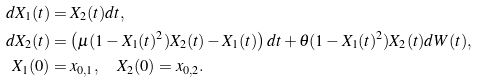Convert formula to latex. <formula><loc_0><loc_0><loc_500><loc_500>d X _ { 1 } ( t ) & = X _ { 2 } ( t ) d t , \\ d X _ { 2 } ( t ) & = \left ( \mu ( 1 - X _ { 1 } ( t ) ^ { 2 } ) X _ { 2 } ( t ) - X _ { 1 } ( t ) \right ) d t + \theta ( 1 - X _ { 1 } ( t ) ^ { 2 } ) X _ { 2 } ( t ) d W ( t ) , \\ X _ { 1 } ( 0 ) & = x _ { 0 , 1 } , \quad X _ { 2 } ( 0 ) = x _ { 0 , 2 } .</formula> 